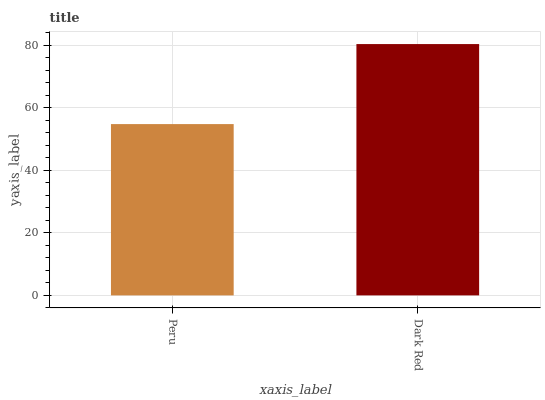Is Peru the minimum?
Answer yes or no. Yes. Is Dark Red the maximum?
Answer yes or no. Yes. Is Dark Red the minimum?
Answer yes or no. No. Is Dark Red greater than Peru?
Answer yes or no. Yes. Is Peru less than Dark Red?
Answer yes or no. Yes. Is Peru greater than Dark Red?
Answer yes or no. No. Is Dark Red less than Peru?
Answer yes or no. No. Is Dark Red the high median?
Answer yes or no. Yes. Is Peru the low median?
Answer yes or no. Yes. Is Peru the high median?
Answer yes or no. No. Is Dark Red the low median?
Answer yes or no. No. 